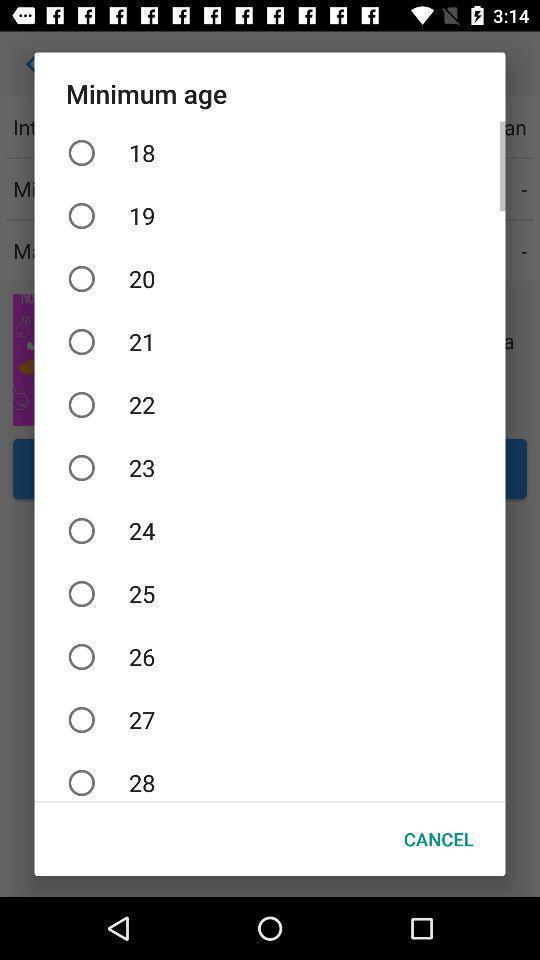Please provide a description for this image. Pop-up asks to select your age. 